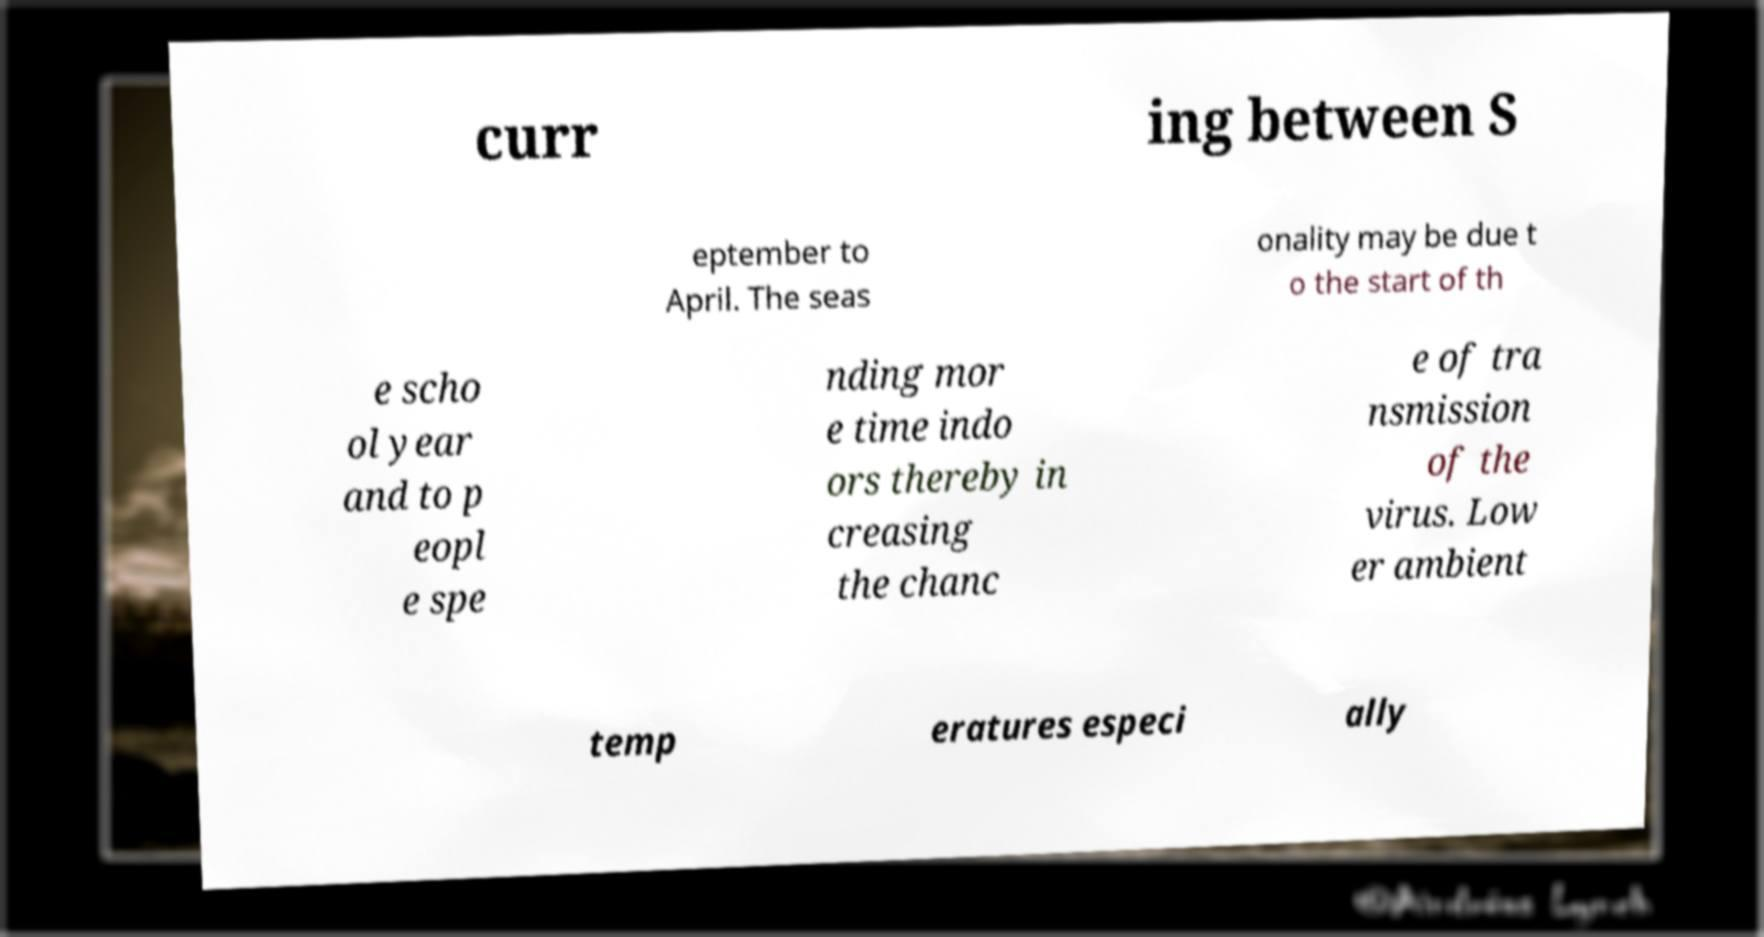There's text embedded in this image that I need extracted. Can you transcribe it verbatim? curr ing between S eptember to April. The seas onality may be due t o the start of th e scho ol year and to p eopl e spe nding mor e time indo ors thereby in creasing the chanc e of tra nsmission of the virus. Low er ambient temp eratures especi ally 